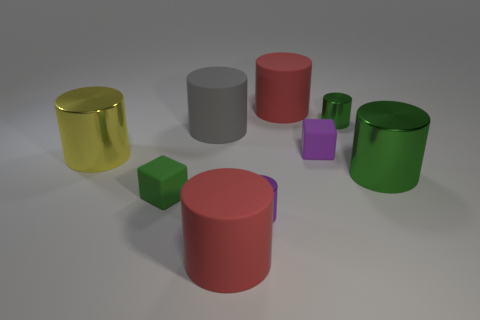What time of day does the lighting in this image suggest? The diffuse, even lighting in the scene doesn't cast strong shadows and appears neutral, resembling indoor lighting or an overcast day where sunlight is masked by clouds. 